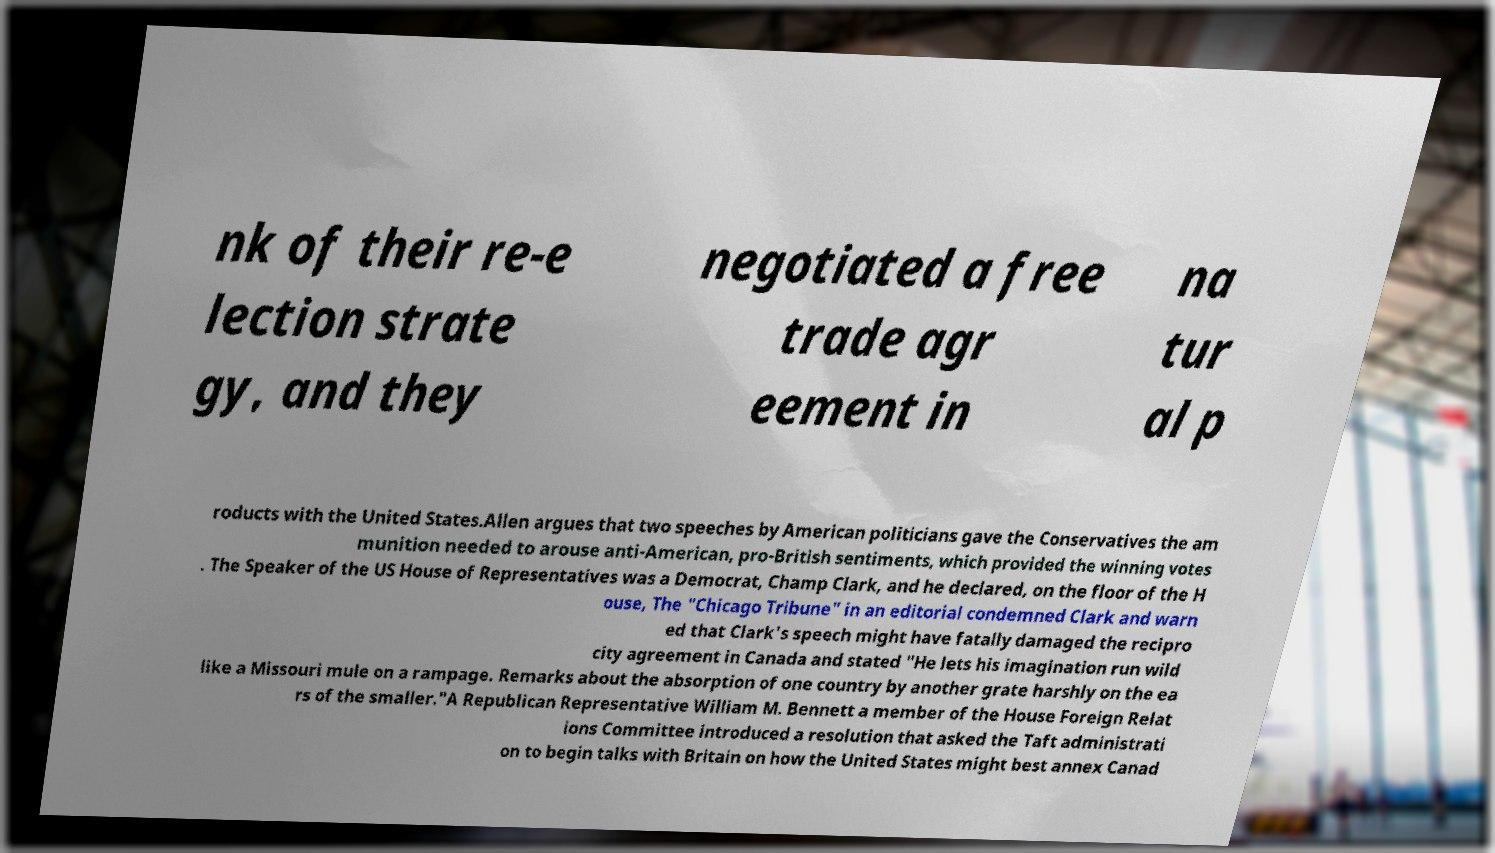Please identify and transcribe the text found in this image. nk of their re-e lection strate gy, and they negotiated a free trade agr eement in na tur al p roducts with the United States.Allen argues that two speeches by American politicians gave the Conservatives the am munition needed to arouse anti-American, pro-British sentiments, which provided the winning votes . The Speaker of the US House of Representatives was a Democrat, Champ Clark, and he declared, on the floor of the H ouse, The "Chicago Tribune" in an editorial condemned Clark and warn ed that Clark's speech might have fatally damaged the recipro city agreement in Canada and stated "He lets his imagination run wild like a Missouri mule on a rampage. Remarks about the absorption of one country by another grate harshly on the ea rs of the smaller."A Republican Representative William M. Bennett a member of the House Foreign Relat ions Committee introduced a resolution that asked the Taft administrati on to begin talks with Britain on how the United States might best annex Canad 